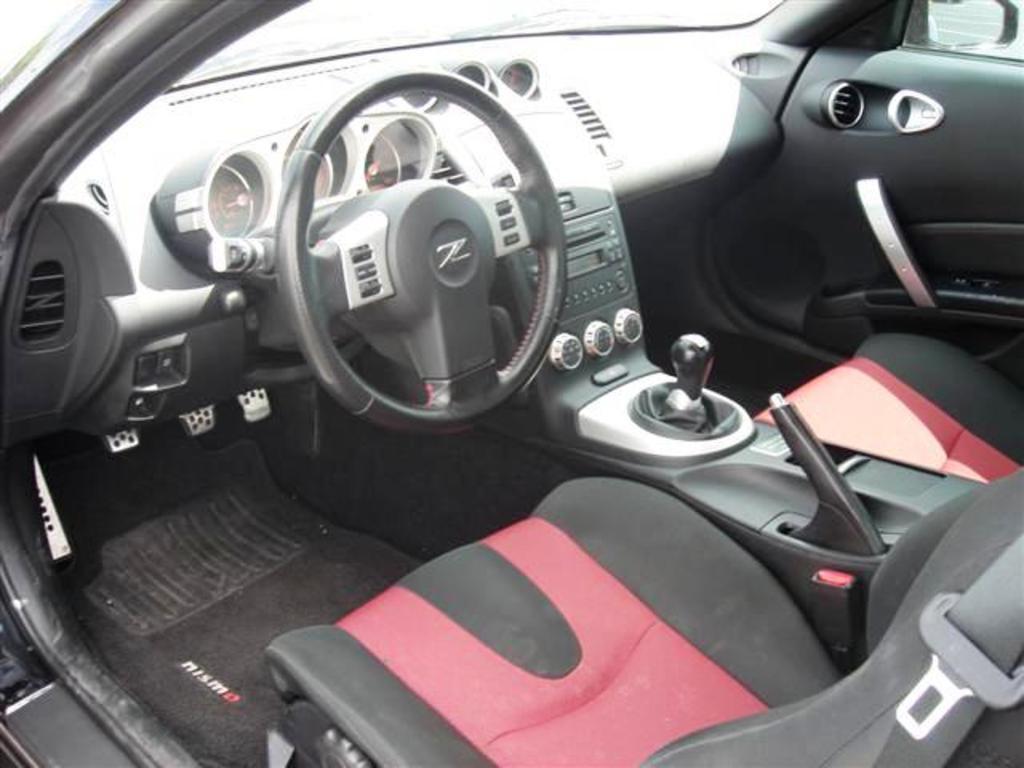In one or two sentences, can you explain what this image depicts? In the image we can see the internal view of the vehicle. Here we can see the seat, steering and dashboard. 